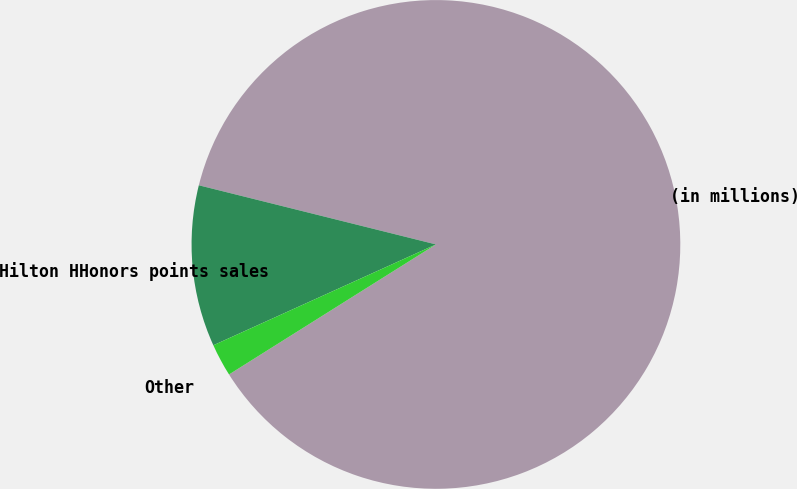<chart> <loc_0><loc_0><loc_500><loc_500><pie_chart><fcel>(in millions)<fcel>Hilton HHonors points sales<fcel>Other<nl><fcel>87.17%<fcel>10.66%<fcel>2.16%<nl></chart> 